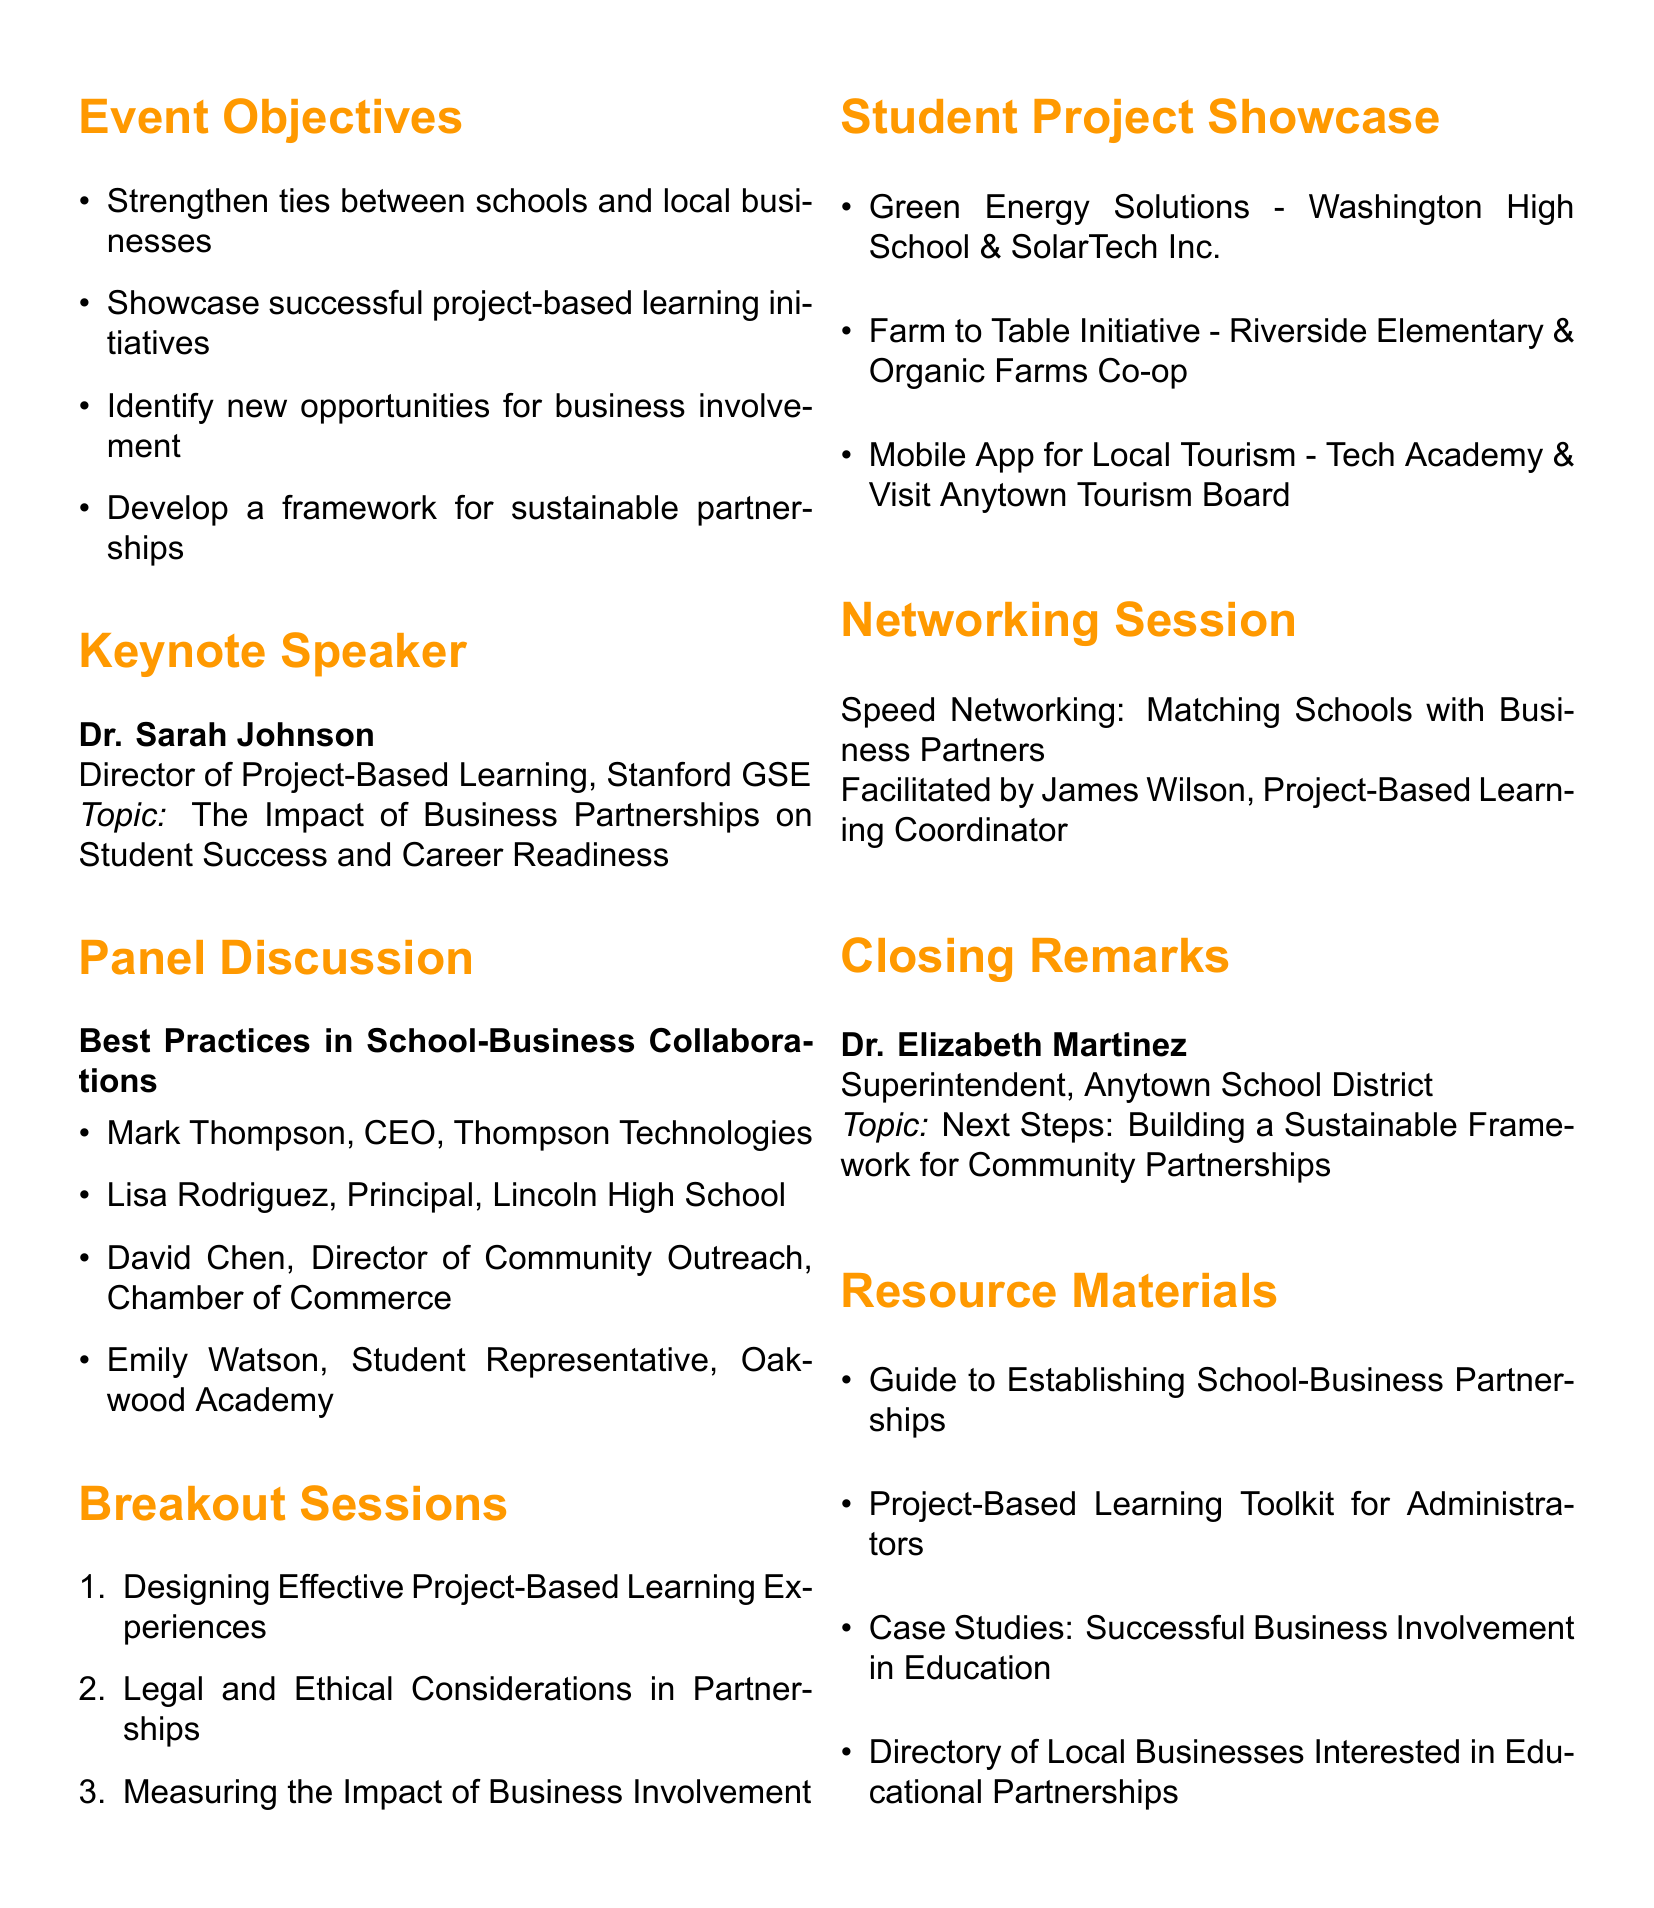What is the title of the event? The title of the event is stated at the beginning of the document.
Answer: Community Partnership Forum: Engaging Local Businesses in Student Projects Who is the keynote speaker? The keynote speaker's name and title are listed under the keynote speaker section of the document.
Answer: Dr. Sarah Johnson What topic will the keynote speaker address? The topic for the keynote speaker is explicitly mentioned in the document.
Answer: The Impact of Business Partnerships on Student Success and Career Readiness How many panelists are there in the panel discussion? The number of panelists can be counted from the list provided in the panel discussion section.
Answer: Four What is one featured project in the student showcase? The document lists several featured projects under the student project showcase.
Answer: Green Energy Solutions Who is facilitating the networking session? The name of the facilitator is mentioned in the networking session section of the document.
Answer: James Wilson What is the main objective of the forum? The main objectives of the forum are provided in a list within the document.
Answer: Strengthen ties between schools and local businesses What is the title of the closing remarks? The title of the closing remarks is included along with the speaker's information in the document.
Answer: Next Steps: Building a Sustainable Framework for Community Partnerships Which organization is Dr. Robert Clark associated with? The document specifies the affiliations of speakers and facilitators under the breakout sessions.
Answer: Educational Research Institute 